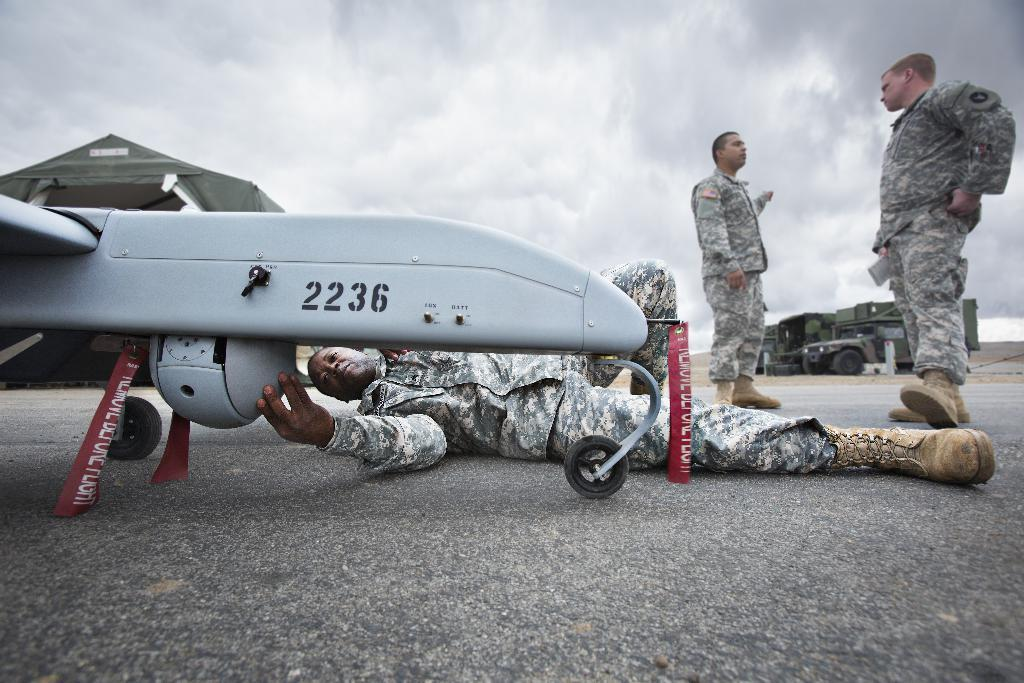<image>
Write a terse but informative summary of the picture. military people looking at a vehicle numbered 2236 